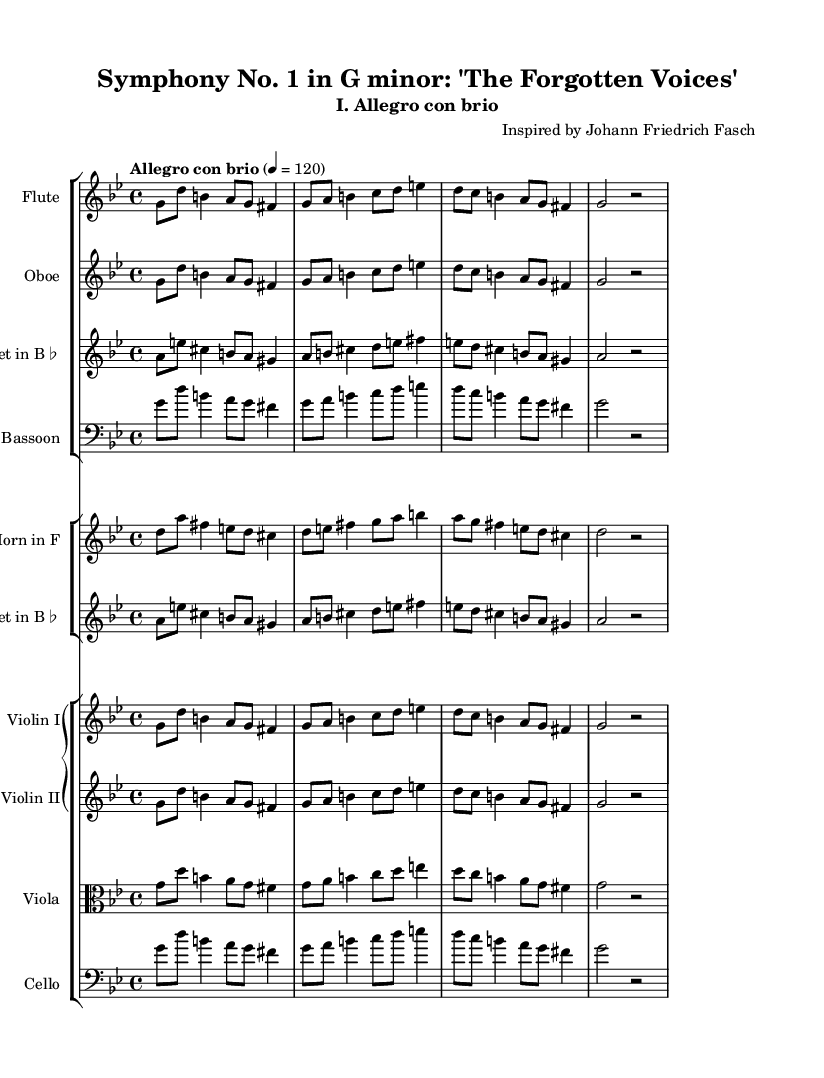What is the key signature of this music? The key signature can be found at the beginning of the staff, indicating which notes are sharp or flat throughout the piece. In this case, the key signature shows two flats which corresponds to G minor.
Answer: G minor What is the time signature of this music? The time signature is located at the beginning of the score, right after the key signature. It indicates how many beats are in a measure and which note value is considered one beat. Here, it shows 4 over 4, meaning there are four beats in a measure, and the quarter note gets the beat.
Answer: 4/4 What is the tempo marking of this movement? The tempo marking appears near the beginning of the score and gives an indication of how fast the music should be played. In this instance, the marking is "Allegro con brio," which means to play fast and with vigor.
Answer: Allegro con brio Which historical composer inspired this symphony? The composer's name is provided in the header of the piece, where it states "Inspired by Johann Friedrich Fasch." This gives context to the influences and stylistic choices present in the symphony.
Answer: Johann Friedrich Fasch How many instrumental groups are there in the symphony? By examining the layout of the score, we can see that there are three distinct staff groups for different families of instruments: woodwinds, brass, and strings. This indicates a diversity of sound and arrangement typical of orchestral music.
Answer: Three What is the main theme's rhythmic pattern in the first measure? The first measure shows a combination of notes and rests that create a specific rhythmic pattern. Here, it starts with two eighth notes followed by a quarter note, another eighth note, then another quarter note. This construction sets the foundation for the thematic material of the movement.
Answer: Eighth, eighth, quarter, eighth, quarter Which instruments are featured in the woodwind section? The instruments in the woodwind section can be identified from the staff labels in the score. The first group consists of flute, oboe, clarinet, and bassoon. This lineup shows the typical orchestration of woodwinds in a neoclassical symphony.
Answer: Flute, Oboe, Clarinet, Bassoon 